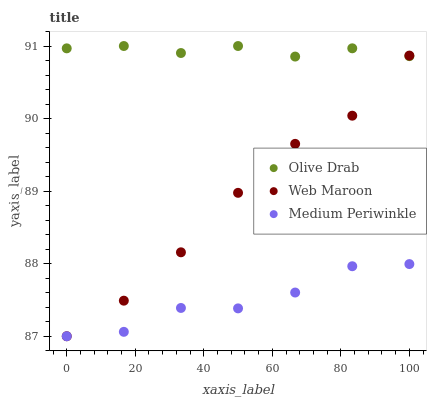Does Medium Periwinkle have the minimum area under the curve?
Answer yes or no. Yes. Does Olive Drab have the maximum area under the curve?
Answer yes or no. Yes. Does Web Maroon have the minimum area under the curve?
Answer yes or no. No. Does Web Maroon have the maximum area under the curve?
Answer yes or no. No. Is Olive Drab the smoothest?
Answer yes or no. Yes. Is Medium Periwinkle the roughest?
Answer yes or no. Yes. Is Web Maroon the smoothest?
Answer yes or no. No. Is Web Maroon the roughest?
Answer yes or no. No. Does Medium Periwinkle have the lowest value?
Answer yes or no. Yes. Does Olive Drab have the lowest value?
Answer yes or no. No. Does Olive Drab have the highest value?
Answer yes or no. Yes. Does Web Maroon have the highest value?
Answer yes or no. No. Is Medium Periwinkle less than Olive Drab?
Answer yes or no. Yes. Is Olive Drab greater than Medium Periwinkle?
Answer yes or no. Yes. Does Web Maroon intersect Medium Periwinkle?
Answer yes or no. Yes. Is Web Maroon less than Medium Periwinkle?
Answer yes or no. No. Is Web Maroon greater than Medium Periwinkle?
Answer yes or no. No. Does Medium Periwinkle intersect Olive Drab?
Answer yes or no. No. 